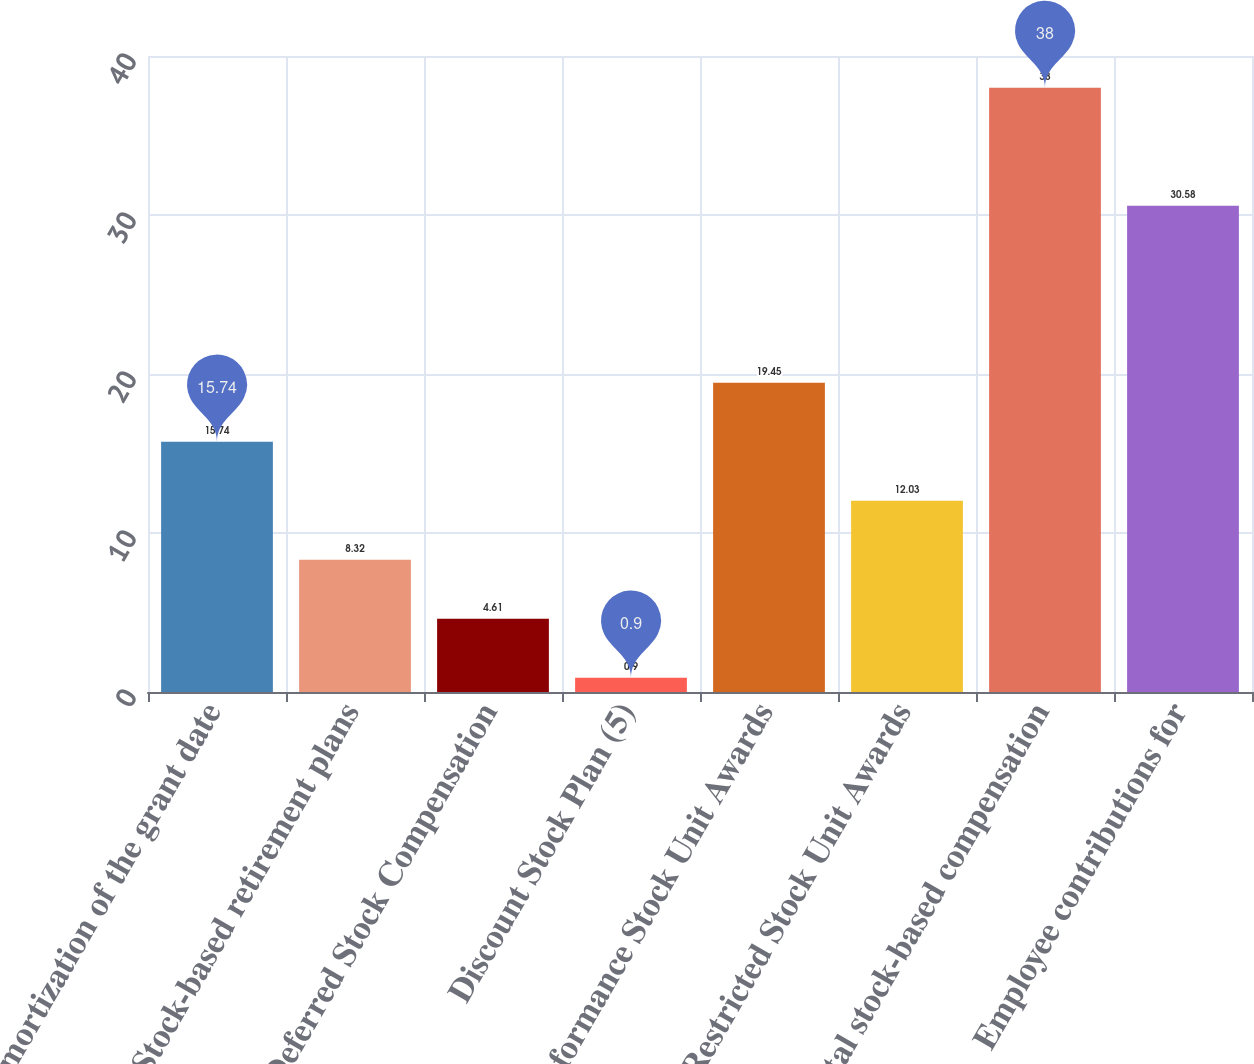<chart> <loc_0><loc_0><loc_500><loc_500><bar_chart><fcel>Amortization of the grant date<fcel>Stock-based retirement plans<fcel>Deferred Stock Compensation<fcel>Discount Stock Plan (5)<fcel>Performance Stock Unit Awards<fcel>Restricted Stock Unit Awards<fcel>Total stock-based compensation<fcel>Employee contributions for<nl><fcel>15.74<fcel>8.32<fcel>4.61<fcel>0.9<fcel>19.45<fcel>12.03<fcel>38<fcel>30.58<nl></chart> 